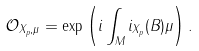Convert formula to latex. <formula><loc_0><loc_0><loc_500><loc_500>\mathcal { O } _ { { X } _ { p } , \mu } = \exp \left ( i \int _ { M } i _ { { X } _ { p } } ( B ) \mu \right ) .</formula> 